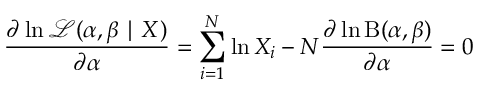<formula> <loc_0><loc_0><loc_500><loc_500>{ \frac { \partial \ln { \mathcal { L } } ( \alpha , \beta | X ) } { \partial \alpha } } = \sum _ { i = 1 } ^ { N } \ln X _ { i } - N { \frac { \partial \ln B ( \alpha , \beta ) } { \partial \alpha } } = 0</formula> 